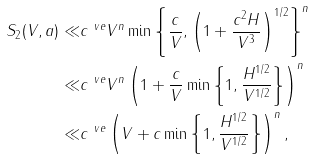<formula> <loc_0><loc_0><loc_500><loc_500>S _ { 2 } ( V , a ) \ll & c ^ { \ v e } V ^ { n } \min \left \{ \frac { c } { V } , \left ( 1 + \frac { c ^ { 2 } H } { V ^ { 3 } } \right ) ^ { 1 / 2 } \right \} ^ { n } \\ \ll & c ^ { \ v e } V ^ { n } \left ( 1 + \frac { c } { V } \min \left \{ 1 , \frac { H ^ { 1 / 2 } } { V ^ { 1 / 2 } } \right \} \right ) ^ { n } \\ \ll & c ^ { \ v e } \left ( V + c \min \left \{ 1 , \frac { H ^ { 1 / 2 } } { V ^ { 1 / 2 } } \right \} \right ) ^ { n } ,</formula> 